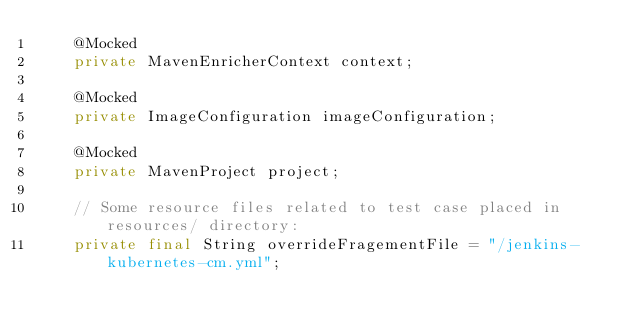Convert code to text. <code><loc_0><loc_0><loc_500><loc_500><_Java_>    @Mocked
    private MavenEnricherContext context;

    @Mocked
    private ImageConfiguration imageConfiguration;

    @Mocked
    private MavenProject project;

    // Some resource files related to test case placed in resources/ directory:
    private final String overrideFragementFile = "/jenkins-kubernetes-cm.yml";</code> 